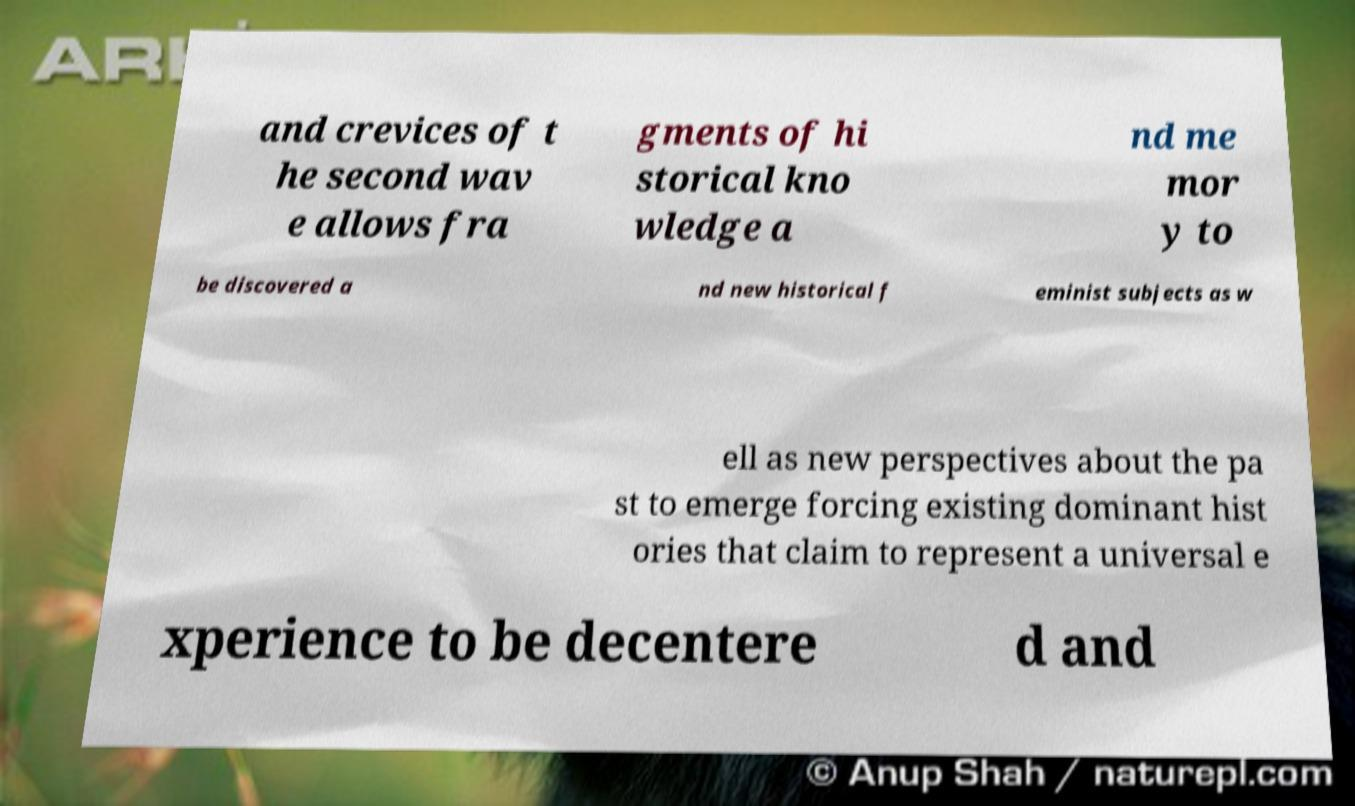Could you assist in decoding the text presented in this image and type it out clearly? and crevices of t he second wav e allows fra gments of hi storical kno wledge a nd me mor y to be discovered a nd new historical f eminist subjects as w ell as new perspectives about the pa st to emerge forcing existing dominant hist ories that claim to represent a universal e xperience to be decentere d and 